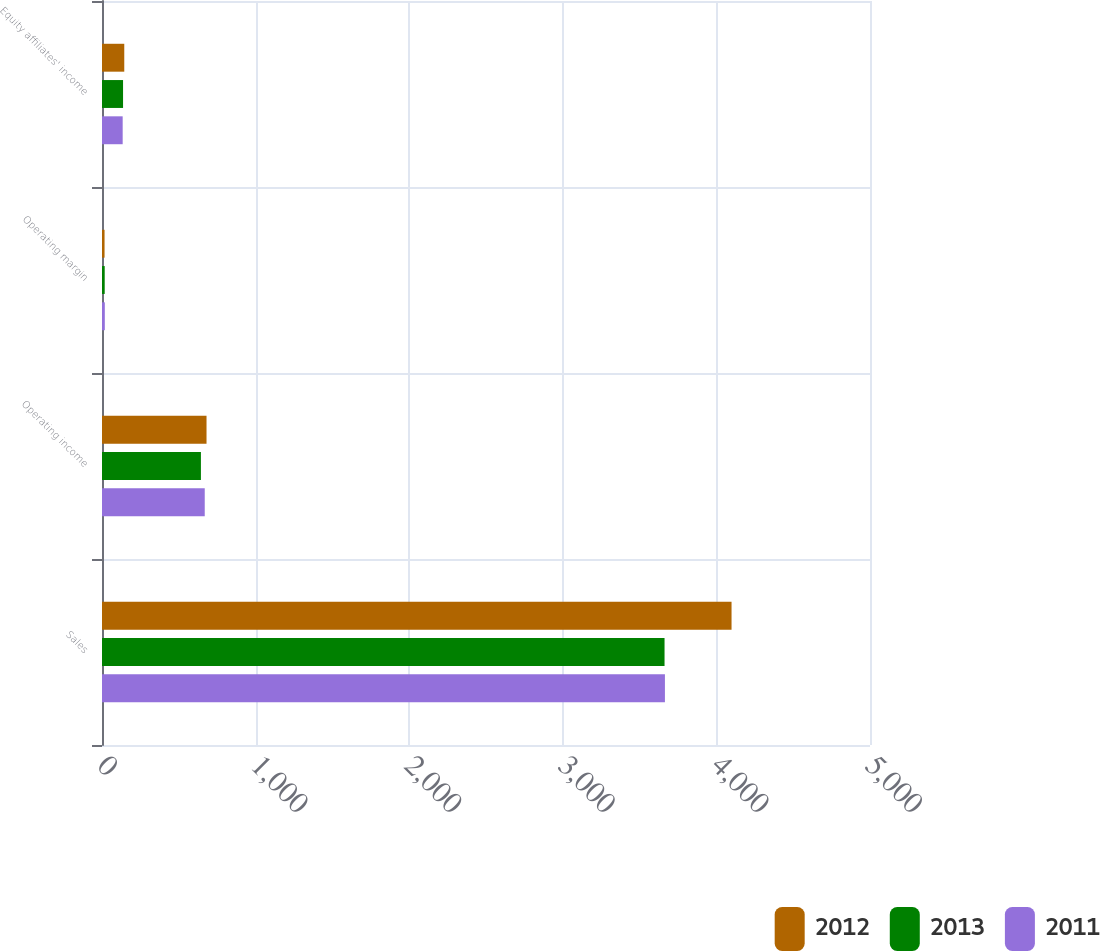Convert chart to OTSL. <chart><loc_0><loc_0><loc_500><loc_500><stacked_bar_chart><ecel><fcel>Sales<fcel>Operating income<fcel>Operating margin<fcel>Equity affiliates' income<nl><fcel>2012<fcel>4098.6<fcel>680.5<fcel>16.6<fcel>145<nl><fcel>2013<fcel>3662.4<fcel>644<fcel>17.6<fcel>137.1<nl><fcel>2011<fcel>3664.9<fcel>668.9<fcel>18.3<fcel>134.6<nl></chart> 